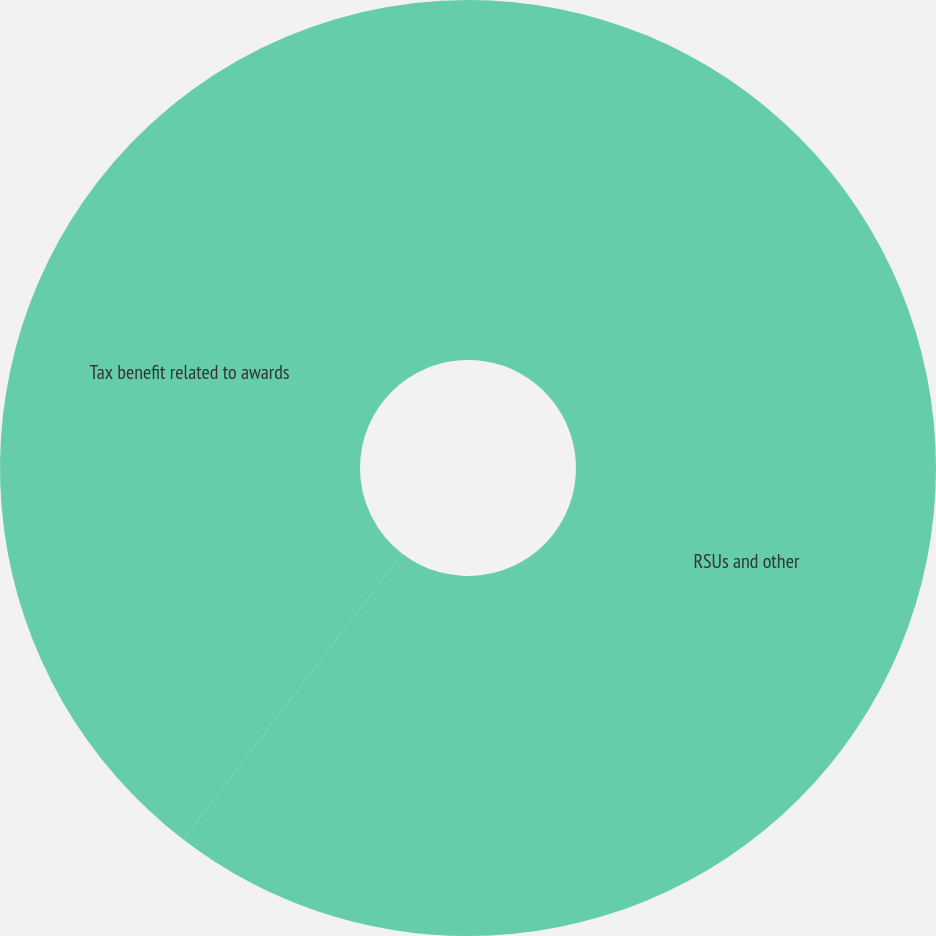Convert chart. <chart><loc_0><loc_0><loc_500><loc_500><pie_chart><fcel>RSUs and other<fcel>Tax benefit related to awards<nl><fcel>60.41%<fcel>39.59%<nl></chart> 